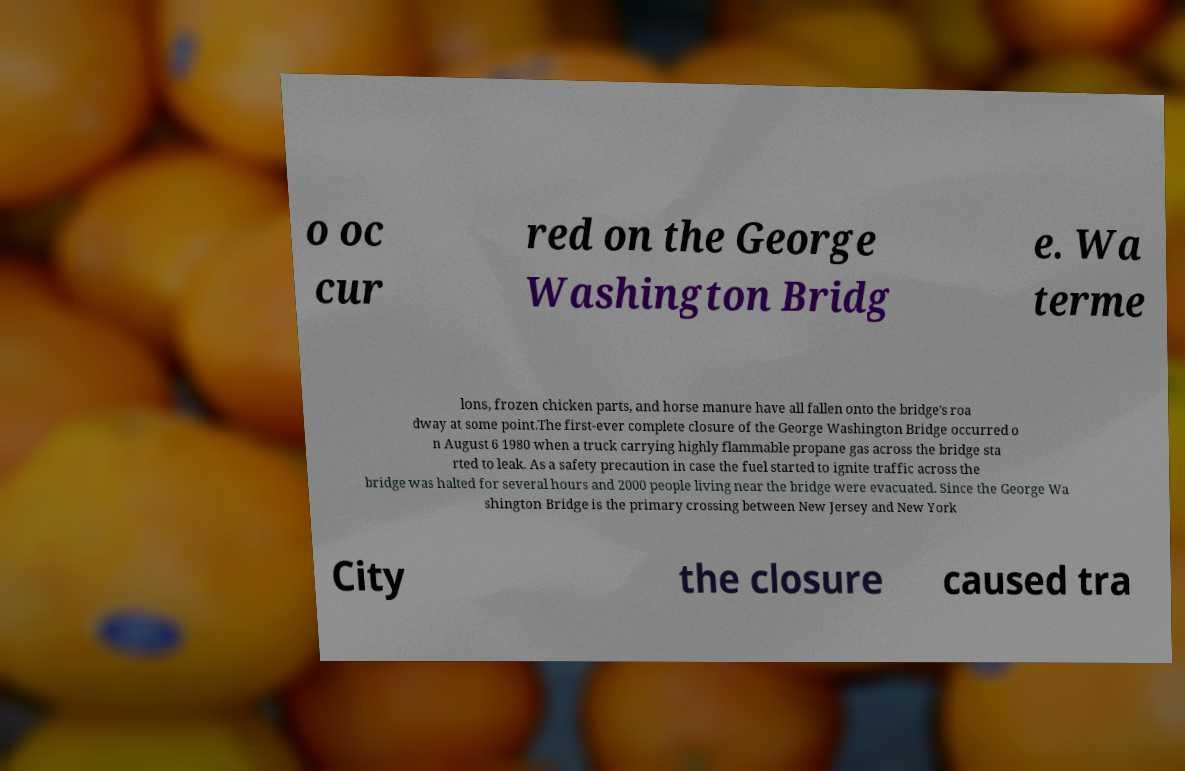For documentation purposes, I need the text within this image transcribed. Could you provide that? o oc cur red on the George Washington Bridg e. Wa terme lons, frozen chicken parts, and horse manure have all fallen onto the bridge's roa dway at some point.The first-ever complete closure of the George Washington Bridge occurred o n August 6 1980 when a truck carrying highly flammable propane gas across the bridge sta rted to leak. As a safety precaution in case the fuel started to ignite traffic across the bridge was halted for several hours and 2000 people living near the bridge were evacuated. Since the George Wa shington Bridge is the primary crossing between New Jersey and New York City the closure caused tra 